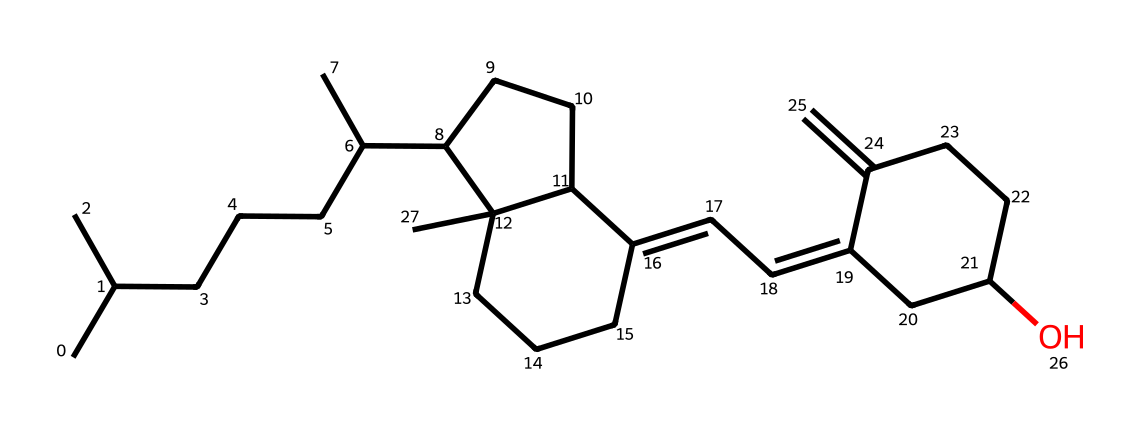What is the molecular formula of vitamin D3? To find the molecular formula, we analyze the number of carbon (C), hydrogen (H), and oxygen (O) atoms present in the SMILES representation. Counting leads us to C27, H44, and O.
Answer: C27H44O How many double bonds are present in the structure? By inspecting the structure, we look for the presence of double bonds, which are typically indicated by the type of connections between carbon atoms. The structure has 2 double bonds identified in the rings and side chains.
Answer: 2 Which functional group is present in vitamin D3? In the chemical structure, the presence of an alcohol (-OH) group at the end of the chain indicates a hydroxyl functional group. This is observed at the final carbon in the ring structure.
Answer: hydroxyl What is the main role of vitamin D3 in mood regulation? Vitamin D3 plays a crucial role as a hormone and influences the expression of genes related to mood and mental health. It is linked to serotonin production, which is a key neurotransmitter affecting mood.
Answer: hormone How does vitamin D3 synthesis occur in the body? Vitamin D3 is synthesized when the skin is exposed to sunlight, specifically ultraviolet B (UVB) rays. The cholesterol derivative in the skin undergoes a chemical transformation to become cholecalciferol.
Answer: sunlight exposure 